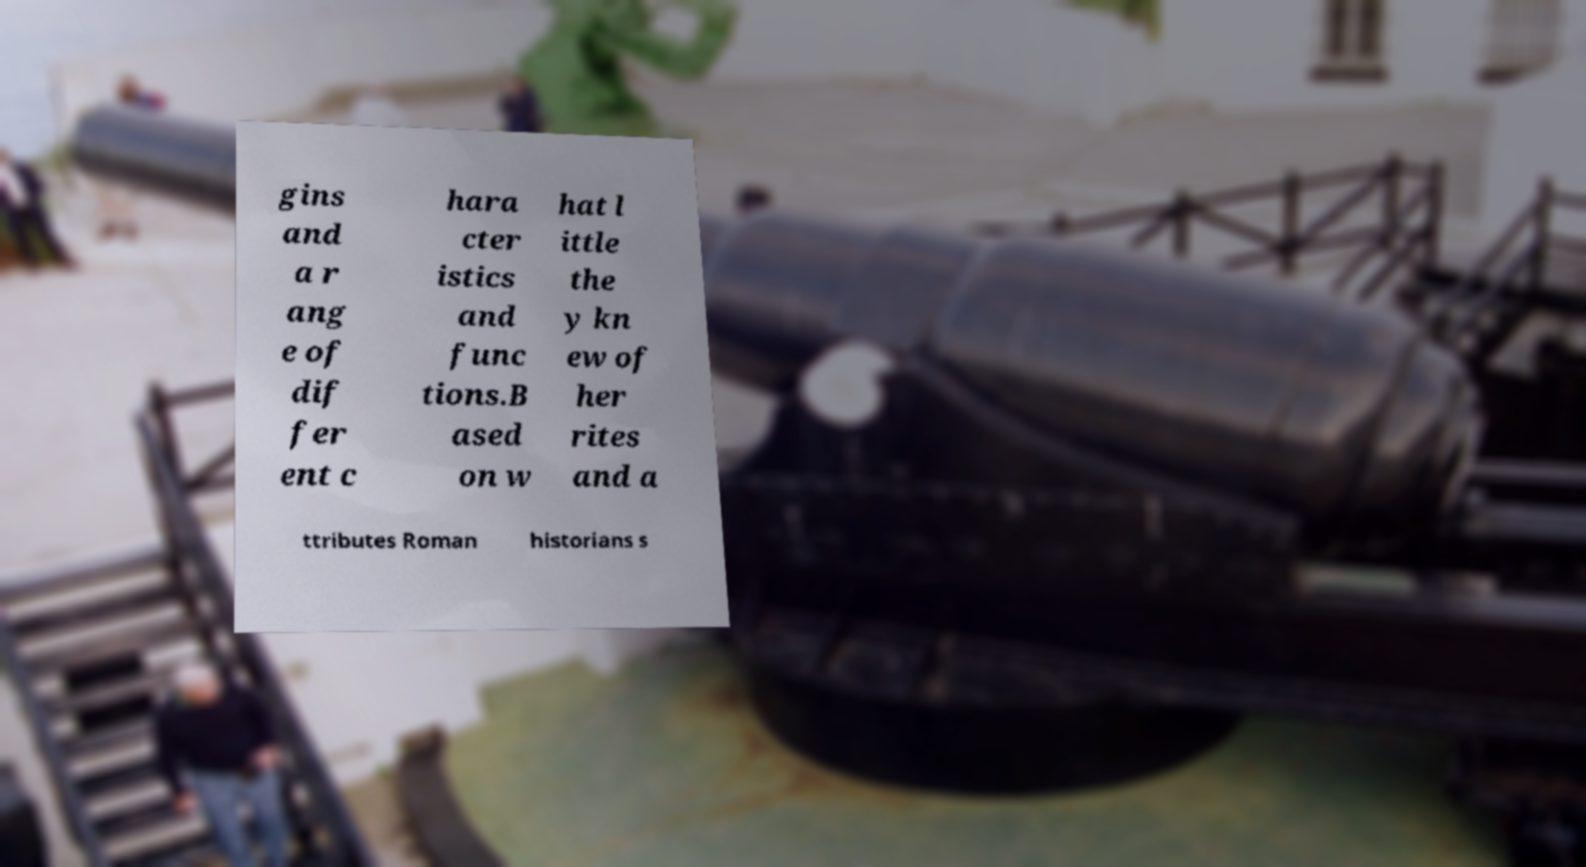Could you extract and type out the text from this image? gins and a r ang e of dif fer ent c hara cter istics and func tions.B ased on w hat l ittle the y kn ew of her rites and a ttributes Roman historians s 